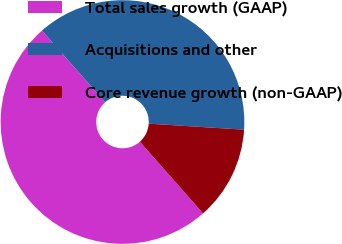Convert chart to OTSL. <chart><loc_0><loc_0><loc_500><loc_500><pie_chart><fcel>Total sales growth (GAAP)<fcel>Acquisitions and other<fcel>Core revenue growth (non-GAAP)<nl><fcel>50.0%<fcel>37.5%<fcel>12.5%<nl></chart> 